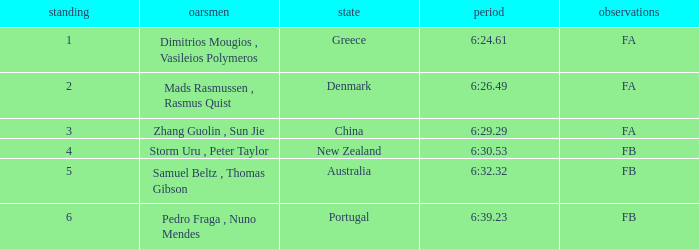What is the names of the rowers that the time was 6:24.61? Dimitrios Mougios , Vasileios Polymeros. 